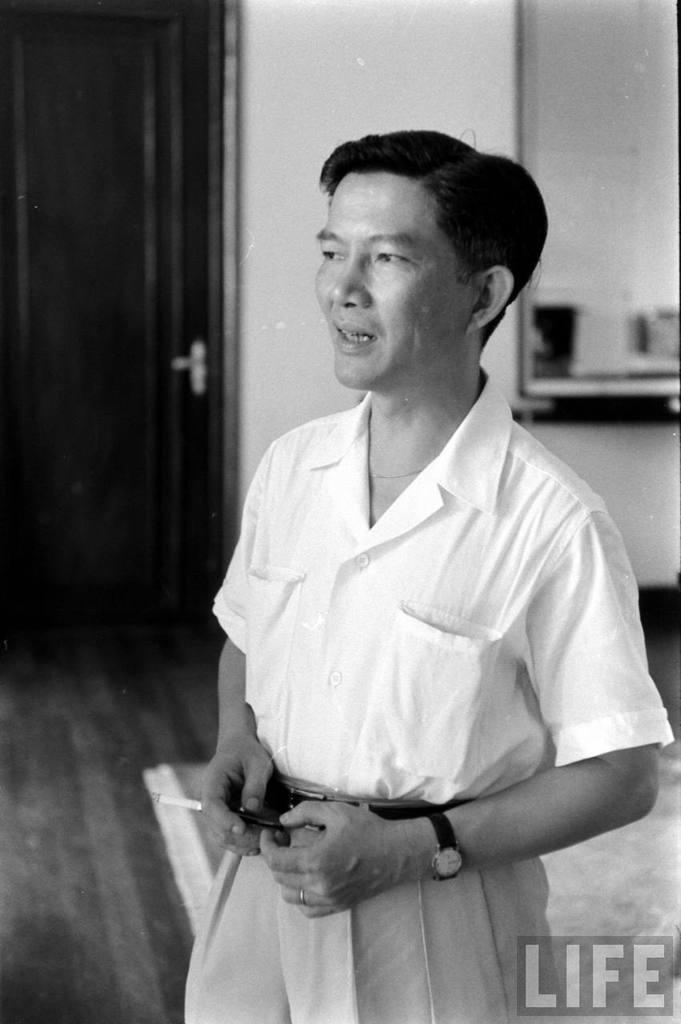Could you give a brief overview of what you see in this image? In this black and white picture a person wearing a shirt is holding a cigarette in his hand. He is standing on the floor having a carpet. Left side there is a door to the wall. 